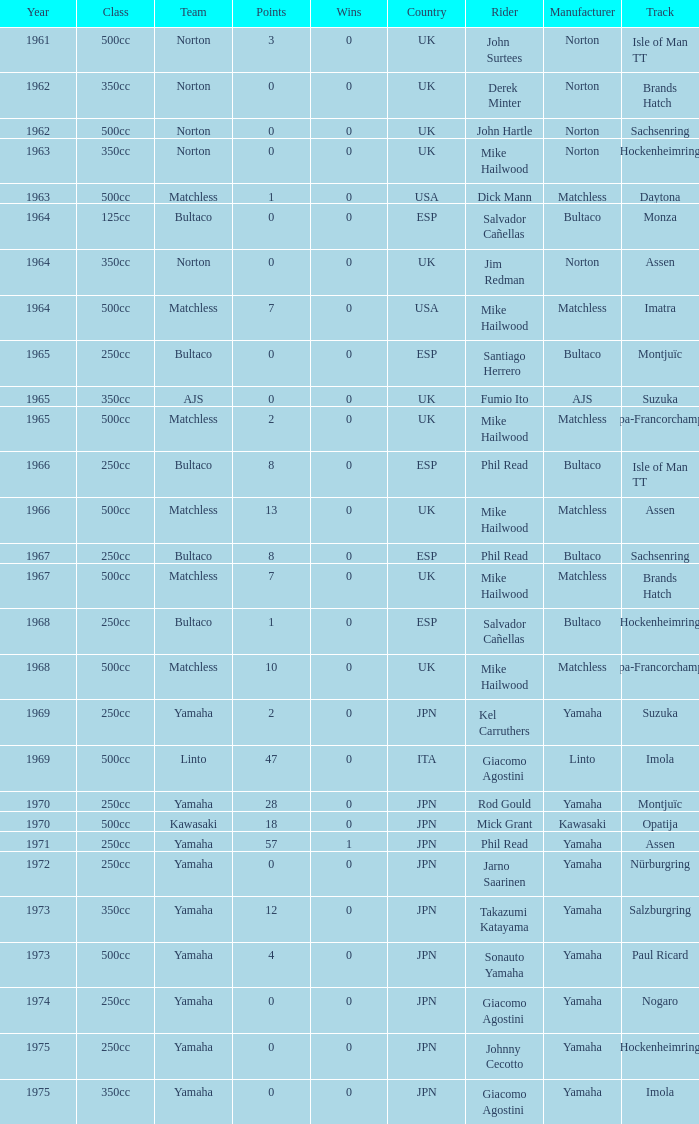What is the sum of all points in 1975 with 0 wins? None. 